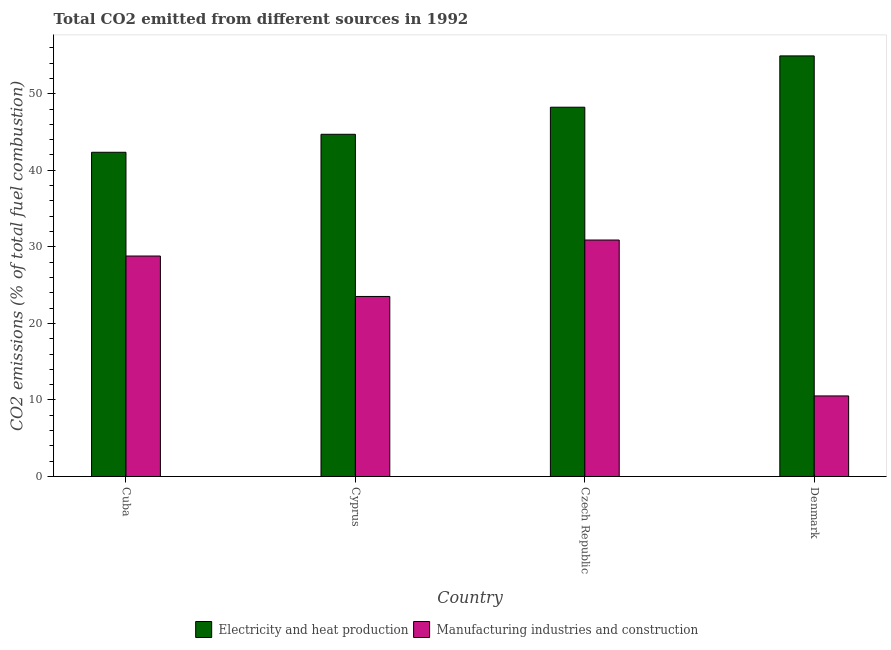How many groups of bars are there?
Offer a very short reply. 4. Are the number of bars per tick equal to the number of legend labels?
Give a very brief answer. Yes. Are the number of bars on each tick of the X-axis equal?
Your answer should be compact. Yes. How many bars are there on the 1st tick from the left?
Offer a very short reply. 2. How many bars are there on the 3rd tick from the right?
Your answer should be compact. 2. What is the label of the 1st group of bars from the left?
Your answer should be very brief. Cuba. In how many cases, is the number of bars for a given country not equal to the number of legend labels?
Provide a short and direct response. 0. What is the co2 emissions due to manufacturing industries in Cyprus?
Offer a very short reply. 23.52. Across all countries, what is the maximum co2 emissions due to electricity and heat production?
Offer a terse response. 54.94. Across all countries, what is the minimum co2 emissions due to electricity and heat production?
Your response must be concise. 42.35. What is the total co2 emissions due to manufacturing industries in the graph?
Provide a short and direct response. 93.73. What is the difference between the co2 emissions due to manufacturing industries in Cyprus and that in Czech Republic?
Provide a short and direct response. -7.37. What is the difference between the co2 emissions due to electricity and heat production in Denmark and the co2 emissions due to manufacturing industries in Czech Republic?
Provide a short and direct response. 24.05. What is the average co2 emissions due to manufacturing industries per country?
Provide a short and direct response. 23.43. What is the difference between the co2 emissions due to electricity and heat production and co2 emissions due to manufacturing industries in Czech Republic?
Provide a short and direct response. 17.35. In how many countries, is the co2 emissions due to electricity and heat production greater than 50 %?
Offer a terse response. 1. What is the ratio of the co2 emissions due to manufacturing industries in Cyprus to that in Czech Republic?
Offer a terse response. 0.76. Is the co2 emissions due to manufacturing industries in Cyprus less than that in Denmark?
Give a very brief answer. No. Is the difference between the co2 emissions due to manufacturing industries in Cuba and Czech Republic greater than the difference between the co2 emissions due to electricity and heat production in Cuba and Czech Republic?
Your answer should be compact. Yes. What is the difference between the highest and the second highest co2 emissions due to manufacturing industries?
Ensure brevity in your answer.  2.09. What is the difference between the highest and the lowest co2 emissions due to electricity and heat production?
Provide a succinct answer. 12.59. What does the 2nd bar from the left in Denmark represents?
Your response must be concise. Manufacturing industries and construction. What does the 1st bar from the right in Cuba represents?
Your answer should be compact. Manufacturing industries and construction. How many countries are there in the graph?
Provide a short and direct response. 4. What is the difference between two consecutive major ticks on the Y-axis?
Provide a succinct answer. 10. Does the graph contain any zero values?
Make the answer very short. No. Does the graph contain grids?
Your response must be concise. No. Where does the legend appear in the graph?
Give a very brief answer. Bottom center. How are the legend labels stacked?
Your response must be concise. Horizontal. What is the title of the graph?
Provide a short and direct response. Total CO2 emitted from different sources in 1992. What is the label or title of the Y-axis?
Offer a terse response. CO2 emissions (% of total fuel combustion). What is the CO2 emissions (% of total fuel combustion) of Electricity and heat production in Cuba?
Your answer should be compact. 42.35. What is the CO2 emissions (% of total fuel combustion) of Manufacturing industries and construction in Cuba?
Provide a short and direct response. 28.8. What is the CO2 emissions (% of total fuel combustion) of Electricity and heat production in Cyprus?
Make the answer very short. 44.7. What is the CO2 emissions (% of total fuel combustion) of Manufacturing industries and construction in Cyprus?
Give a very brief answer. 23.52. What is the CO2 emissions (% of total fuel combustion) of Electricity and heat production in Czech Republic?
Provide a succinct answer. 48.24. What is the CO2 emissions (% of total fuel combustion) of Manufacturing industries and construction in Czech Republic?
Make the answer very short. 30.89. What is the CO2 emissions (% of total fuel combustion) in Electricity and heat production in Denmark?
Keep it short and to the point. 54.94. What is the CO2 emissions (% of total fuel combustion) of Manufacturing industries and construction in Denmark?
Provide a succinct answer. 10.52. Across all countries, what is the maximum CO2 emissions (% of total fuel combustion) in Electricity and heat production?
Your response must be concise. 54.94. Across all countries, what is the maximum CO2 emissions (% of total fuel combustion) of Manufacturing industries and construction?
Provide a short and direct response. 30.89. Across all countries, what is the minimum CO2 emissions (% of total fuel combustion) in Electricity and heat production?
Ensure brevity in your answer.  42.35. Across all countries, what is the minimum CO2 emissions (% of total fuel combustion) of Manufacturing industries and construction?
Make the answer very short. 10.52. What is the total CO2 emissions (% of total fuel combustion) of Electricity and heat production in the graph?
Keep it short and to the point. 190.24. What is the total CO2 emissions (% of total fuel combustion) in Manufacturing industries and construction in the graph?
Provide a short and direct response. 93.73. What is the difference between the CO2 emissions (% of total fuel combustion) of Electricity and heat production in Cuba and that in Cyprus?
Your response must be concise. -2.35. What is the difference between the CO2 emissions (% of total fuel combustion) of Manufacturing industries and construction in Cuba and that in Cyprus?
Offer a very short reply. 5.28. What is the difference between the CO2 emissions (% of total fuel combustion) of Electricity and heat production in Cuba and that in Czech Republic?
Provide a short and direct response. -5.89. What is the difference between the CO2 emissions (% of total fuel combustion) in Manufacturing industries and construction in Cuba and that in Czech Republic?
Your answer should be very brief. -2.09. What is the difference between the CO2 emissions (% of total fuel combustion) of Electricity and heat production in Cuba and that in Denmark?
Provide a succinct answer. -12.59. What is the difference between the CO2 emissions (% of total fuel combustion) of Manufacturing industries and construction in Cuba and that in Denmark?
Your answer should be very brief. 18.28. What is the difference between the CO2 emissions (% of total fuel combustion) of Electricity and heat production in Cyprus and that in Czech Republic?
Your response must be concise. -3.54. What is the difference between the CO2 emissions (% of total fuel combustion) in Manufacturing industries and construction in Cyprus and that in Czech Republic?
Make the answer very short. -7.37. What is the difference between the CO2 emissions (% of total fuel combustion) in Electricity and heat production in Cyprus and that in Denmark?
Ensure brevity in your answer.  -10.24. What is the difference between the CO2 emissions (% of total fuel combustion) in Manufacturing industries and construction in Cyprus and that in Denmark?
Your response must be concise. 12.99. What is the difference between the CO2 emissions (% of total fuel combustion) of Electricity and heat production in Czech Republic and that in Denmark?
Keep it short and to the point. -6.7. What is the difference between the CO2 emissions (% of total fuel combustion) in Manufacturing industries and construction in Czech Republic and that in Denmark?
Keep it short and to the point. 20.37. What is the difference between the CO2 emissions (% of total fuel combustion) in Electricity and heat production in Cuba and the CO2 emissions (% of total fuel combustion) in Manufacturing industries and construction in Cyprus?
Give a very brief answer. 18.84. What is the difference between the CO2 emissions (% of total fuel combustion) in Electricity and heat production in Cuba and the CO2 emissions (% of total fuel combustion) in Manufacturing industries and construction in Czech Republic?
Ensure brevity in your answer.  11.46. What is the difference between the CO2 emissions (% of total fuel combustion) in Electricity and heat production in Cuba and the CO2 emissions (% of total fuel combustion) in Manufacturing industries and construction in Denmark?
Your answer should be compact. 31.83. What is the difference between the CO2 emissions (% of total fuel combustion) of Electricity and heat production in Cyprus and the CO2 emissions (% of total fuel combustion) of Manufacturing industries and construction in Czech Republic?
Offer a very short reply. 13.81. What is the difference between the CO2 emissions (% of total fuel combustion) in Electricity and heat production in Cyprus and the CO2 emissions (% of total fuel combustion) in Manufacturing industries and construction in Denmark?
Your answer should be compact. 34.18. What is the difference between the CO2 emissions (% of total fuel combustion) in Electricity and heat production in Czech Republic and the CO2 emissions (% of total fuel combustion) in Manufacturing industries and construction in Denmark?
Keep it short and to the point. 37.72. What is the average CO2 emissions (% of total fuel combustion) in Electricity and heat production per country?
Ensure brevity in your answer.  47.56. What is the average CO2 emissions (% of total fuel combustion) of Manufacturing industries and construction per country?
Provide a short and direct response. 23.43. What is the difference between the CO2 emissions (% of total fuel combustion) in Electricity and heat production and CO2 emissions (% of total fuel combustion) in Manufacturing industries and construction in Cuba?
Your answer should be very brief. 13.55. What is the difference between the CO2 emissions (% of total fuel combustion) in Electricity and heat production and CO2 emissions (% of total fuel combustion) in Manufacturing industries and construction in Cyprus?
Your response must be concise. 21.19. What is the difference between the CO2 emissions (% of total fuel combustion) of Electricity and heat production and CO2 emissions (% of total fuel combustion) of Manufacturing industries and construction in Czech Republic?
Provide a short and direct response. 17.35. What is the difference between the CO2 emissions (% of total fuel combustion) of Electricity and heat production and CO2 emissions (% of total fuel combustion) of Manufacturing industries and construction in Denmark?
Make the answer very short. 44.42. What is the ratio of the CO2 emissions (% of total fuel combustion) in Electricity and heat production in Cuba to that in Cyprus?
Your answer should be very brief. 0.95. What is the ratio of the CO2 emissions (% of total fuel combustion) in Manufacturing industries and construction in Cuba to that in Cyprus?
Make the answer very short. 1.22. What is the ratio of the CO2 emissions (% of total fuel combustion) in Electricity and heat production in Cuba to that in Czech Republic?
Offer a very short reply. 0.88. What is the ratio of the CO2 emissions (% of total fuel combustion) of Manufacturing industries and construction in Cuba to that in Czech Republic?
Keep it short and to the point. 0.93. What is the ratio of the CO2 emissions (% of total fuel combustion) of Electricity and heat production in Cuba to that in Denmark?
Your answer should be compact. 0.77. What is the ratio of the CO2 emissions (% of total fuel combustion) of Manufacturing industries and construction in Cuba to that in Denmark?
Provide a short and direct response. 2.74. What is the ratio of the CO2 emissions (% of total fuel combustion) of Electricity and heat production in Cyprus to that in Czech Republic?
Make the answer very short. 0.93. What is the ratio of the CO2 emissions (% of total fuel combustion) of Manufacturing industries and construction in Cyprus to that in Czech Republic?
Keep it short and to the point. 0.76. What is the ratio of the CO2 emissions (% of total fuel combustion) in Electricity and heat production in Cyprus to that in Denmark?
Your response must be concise. 0.81. What is the ratio of the CO2 emissions (% of total fuel combustion) in Manufacturing industries and construction in Cyprus to that in Denmark?
Give a very brief answer. 2.23. What is the ratio of the CO2 emissions (% of total fuel combustion) of Electricity and heat production in Czech Republic to that in Denmark?
Provide a short and direct response. 0.88. What is the ratio of the CO2 emissions (% of total fuel combustion) in Manufacturing industries and construction in Czech Republic to that in Denmark?
Your answer should be compact. 2.94. What is the difference between the highest and the second highest CO2 emissions (% of total fuel combustion) of Electricity and heat production?
Provide a succinct answer. 6.7. What is the difference between the highest and the second highest CO2 emissions (% of total fuel combustion) in Manufacturing industries and construction?
Keep it short and to the point. 2.09. What is the difference between the highest and the lowest CO2 emissions (% of total fuel combustion) in Electricity and heat production?
Ensure brevity in your answer.  12.59. What is the difference between the highest and the lowest CO2 emissions (% of total fuel combustion) of Manufacturing industries and construction?
Provide a short and direct response. 20.37. 